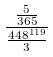Convert formula to latex. <formula><loc_0><loc_0><loc_500><loc_500>\frac { \frac { 5 } { 3 6 5 } } { \frac { 4 4 8 ^ { 1 1 9 } } { 3 } }</formula> 